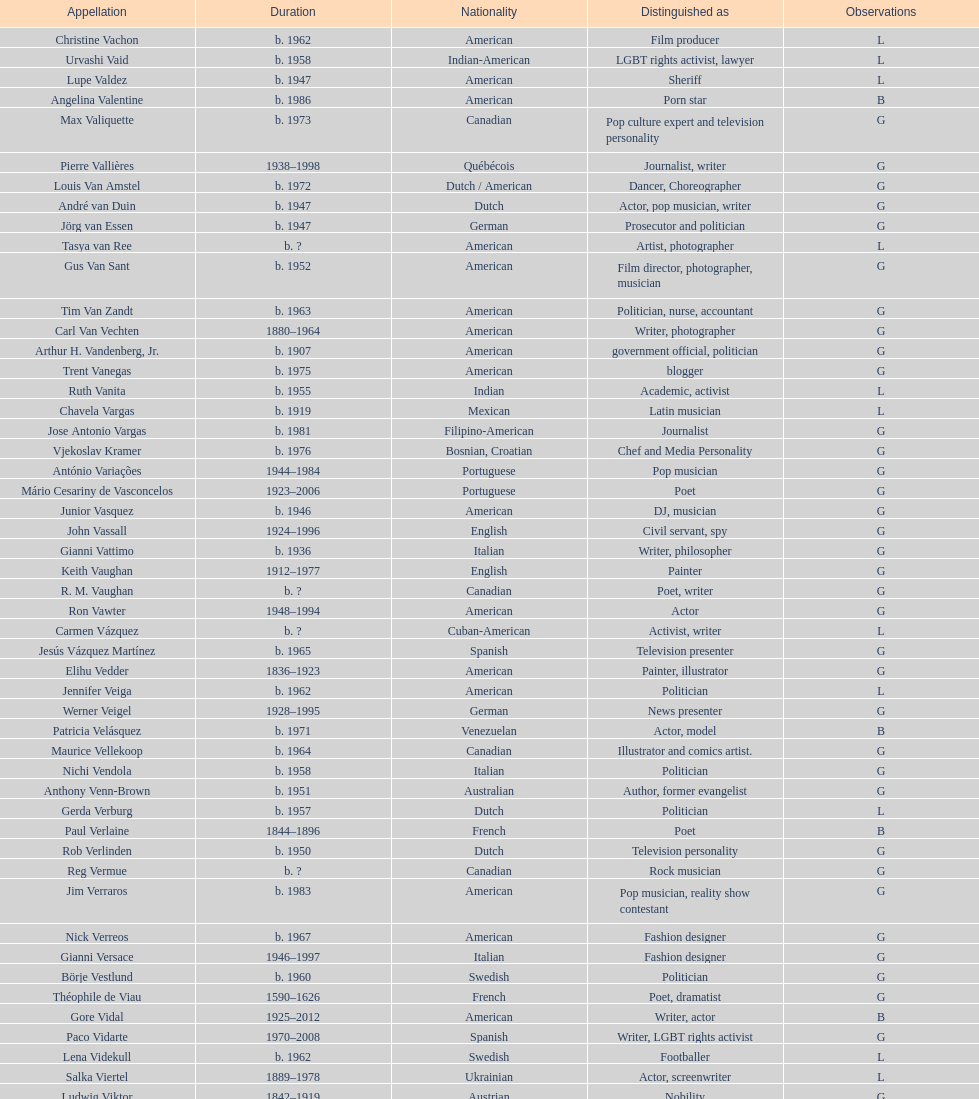What is the number of individuals in this group who were indian? 1. 